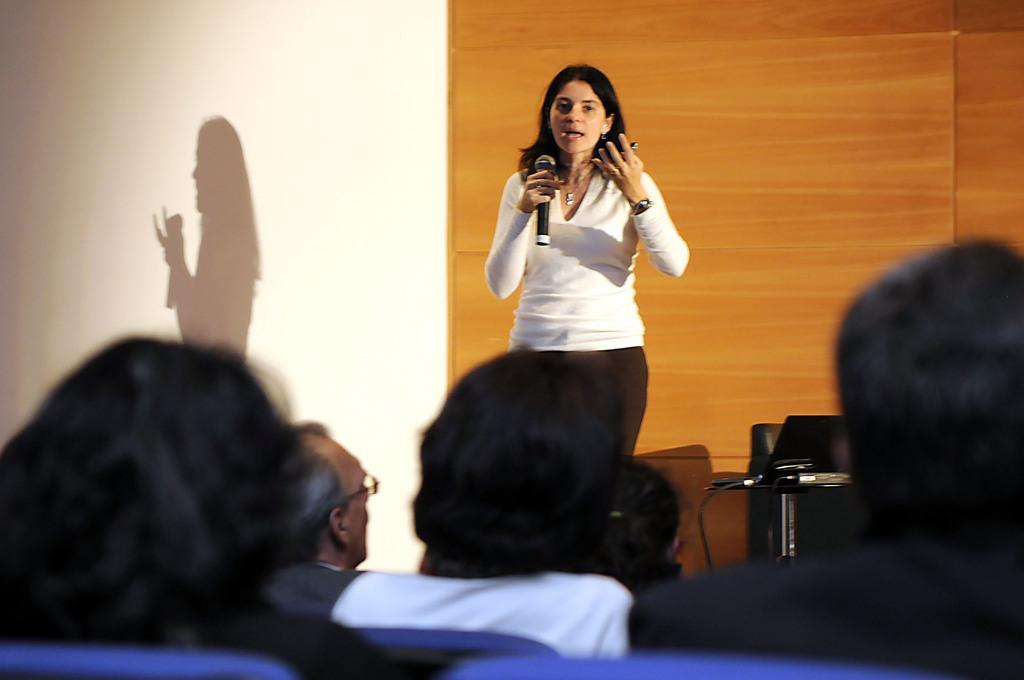How would you summarize this image in a sentence or two? In this picture we can see a lady holding a mike and speaking to people sitting in front of her. 